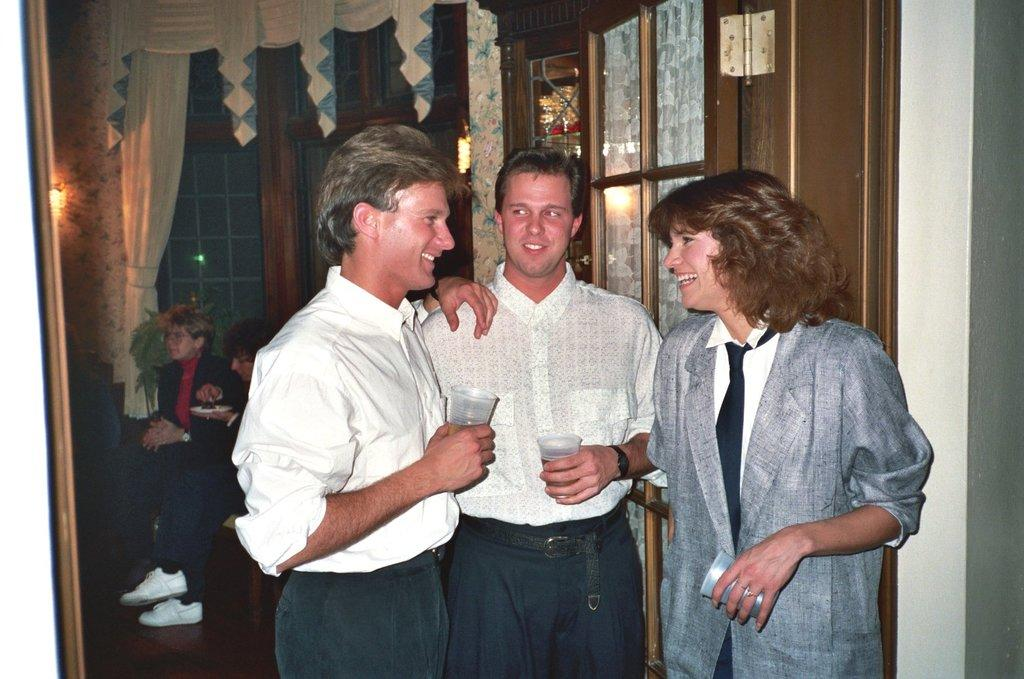How many people are in the foreground of the picture? There are three people in the foreground of the picture. What objects are in the foreground of the picture? There is a door and a wall in the foreground of the picture. What can be seen in the background of the picture? In the background of the picture, there are curtains, windows, light, and other objects. How many sheep are visible in the picture? There are no sheep present in the picture. What direction are the people in the picture looking? The provided facts do not mention the direction the people are looking, so we cannot answer this question definitively. 